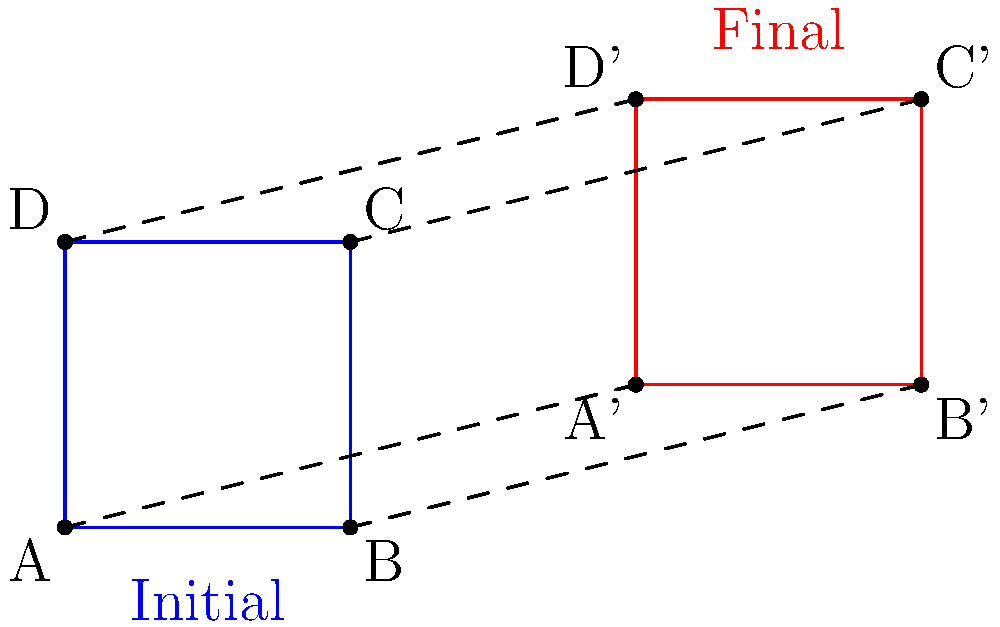As a tech blogger, you're creating an animation for a new smartphone's transition from its folded to unfolded state. The initial state is represented by the blue rectangle ABCD, and the final state by the red rectangle A'B'C'D'. Describe the sequence of transformations needed to animate this transition, given that the smartphone first translates, then rotates slightly, and finally scales to its full size. Express the final transformation matrix as a product of individual transformation matrices. Let's break this down step-by-step:

1. Translation: The center of the rectangle moves from (1,1) to (5,2). This is a translation by (4,1).
   Translation matrix: $T = \begin{bmatrix} 1 & 0 & 4 \\ 0 & 1 & 1 \\ 0 & 0 & 1 \end{bmatrix}$

2. Rotation: There's a slight clockwise rotation. Let's assume it's about 5° (0.0873 radians).
   Rotation matrix: $R = \begin{bmatrix} \cos(-0.0873) & -\sin(-0.0873) & 0 \\ \sin(-0.0873) & \cos(-0.0873) & 0 \\ 0 & 0 & 1 \end{bmatrix}$

3. Scaling: The rectangle expands slightly. Let's say it scales by a factor of 1.1 in both directions.
   Scaling matrix: $S = \begin{bmatrix} 1.1 & 0 & 0 \\ 0 & 1.1 & 0 \\ 0 & 0 & 1 \end{bmatrix}$

The final transformation matrix is the product of these matrices in reverse order:

$M = T \cdot R \cdot S$

Multiplying these matrices:

$M = \begin{bmatrix} 1 & 0 & 4 \\ 0 & 1 & 1 \\ 0 & 0 & 1 \end{bmatrix} \cdot \begin{bmatrix} 0.9962 & 0.0872 & 0 \\ -0.0872 & 0.9962 & 0 \\ 0 & 0 & 1 \end{bmatrix} \cdot \begin{bmatrix} 1.1 & 0 & 0 \\ 0 & 1.1 & 0 \\ 0 & 0 & 1 \end{bmatrix}$

$M = \begin{bmatrix} 1.0958 & 0.0959 & 4 \\ -0.0959 & 1.0958 & 1 \\ 0 & 0 & 1 \end{bmatrix}$

This final matrix $M$ represents the complete transformation from the initial to the final state of the smartphone.
Answer: $M = \begin{bmatrix} 1.0958 & 0.0959 & 4 \\ -0.0959 & 1.0958 & 1 \\ 0 & 0 & 1 \end{bmatrix}$ 